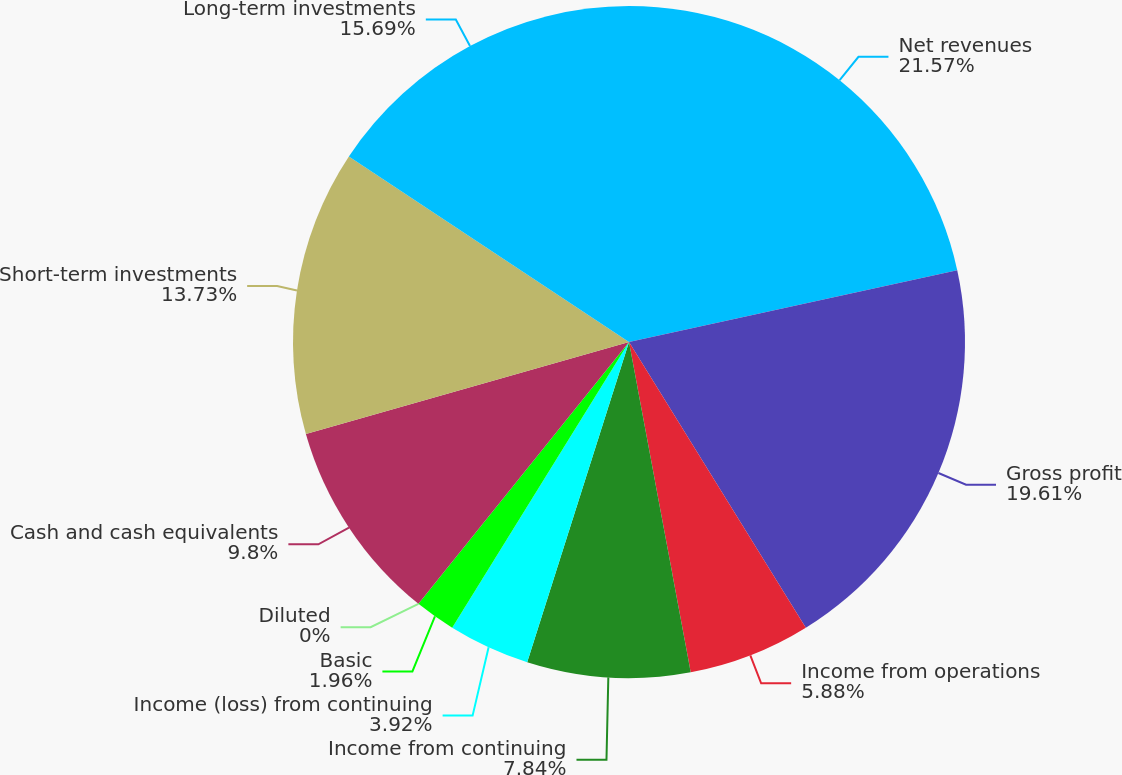Convert chart to OTSL. <chart><loc_0><loc_0><loc_500><loc_500><pie_chart><fcel>Net revenues<fcel>Gross profit<fcel>Income from operations<fcel>Income from continuing<fcel>Income (loss) from continuing<fcel>Basic<fcel>Diluted<fcel>Cash and cash equivalents<fcel>Short-term investments<fcel>Long-term investments<nl><fcel>21.57%<fcel>19.61%<fcel>5.88%<fcel>7.84%<fcel>3.92%<fcel>1.96%<fcel>0.0%<fcel>9.8%<fcel>13.73%<fcel>15.69%<nl></chart> 